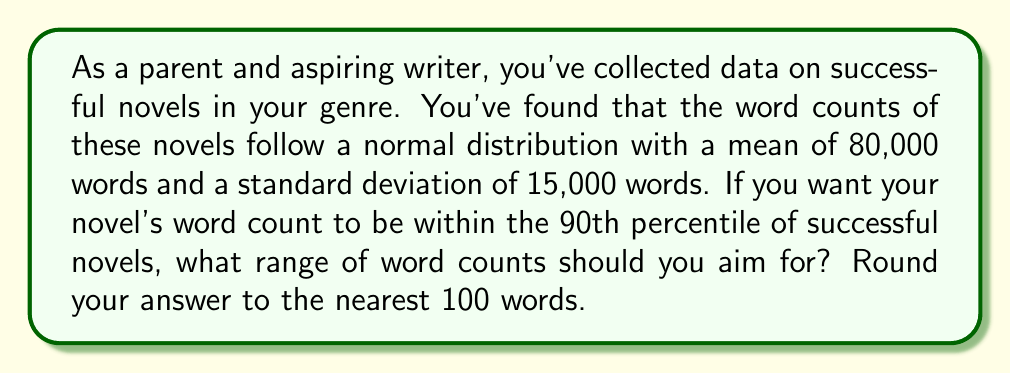Provide a solution to this math problem. To solve this problem, we'll follow these steps:

1) For a normal distribution, the 90th percentile includes all values within 1.645 standard deviations of the mean (in both directions).

2) We're given:
   Mean (μ) = 80,000 words
   Standard deviation (σ) = 15,000 words

3) The range is calculated as:
   Lower bound: μ - 1.645σ
   Upper bound: μ + 1.645σ

4) Let's calculate:
   Lower bound: $80,000 - 1.645 * 15,000 = 80,000 - 24,675 = 55,325$
   Upper bound: $80,000 + 1.645 * 15,000 = 80,000 + 24,675 = 104,675$

5) Rounding to the nearest 100 words:
   Lower bound: 55,300 words
   Upper bound: 104,700 words

Therefore, to be within the 90th percentile, the novel should have between 55,300 and 104,700 words.
Answer: 55,300 to 104,700 words 